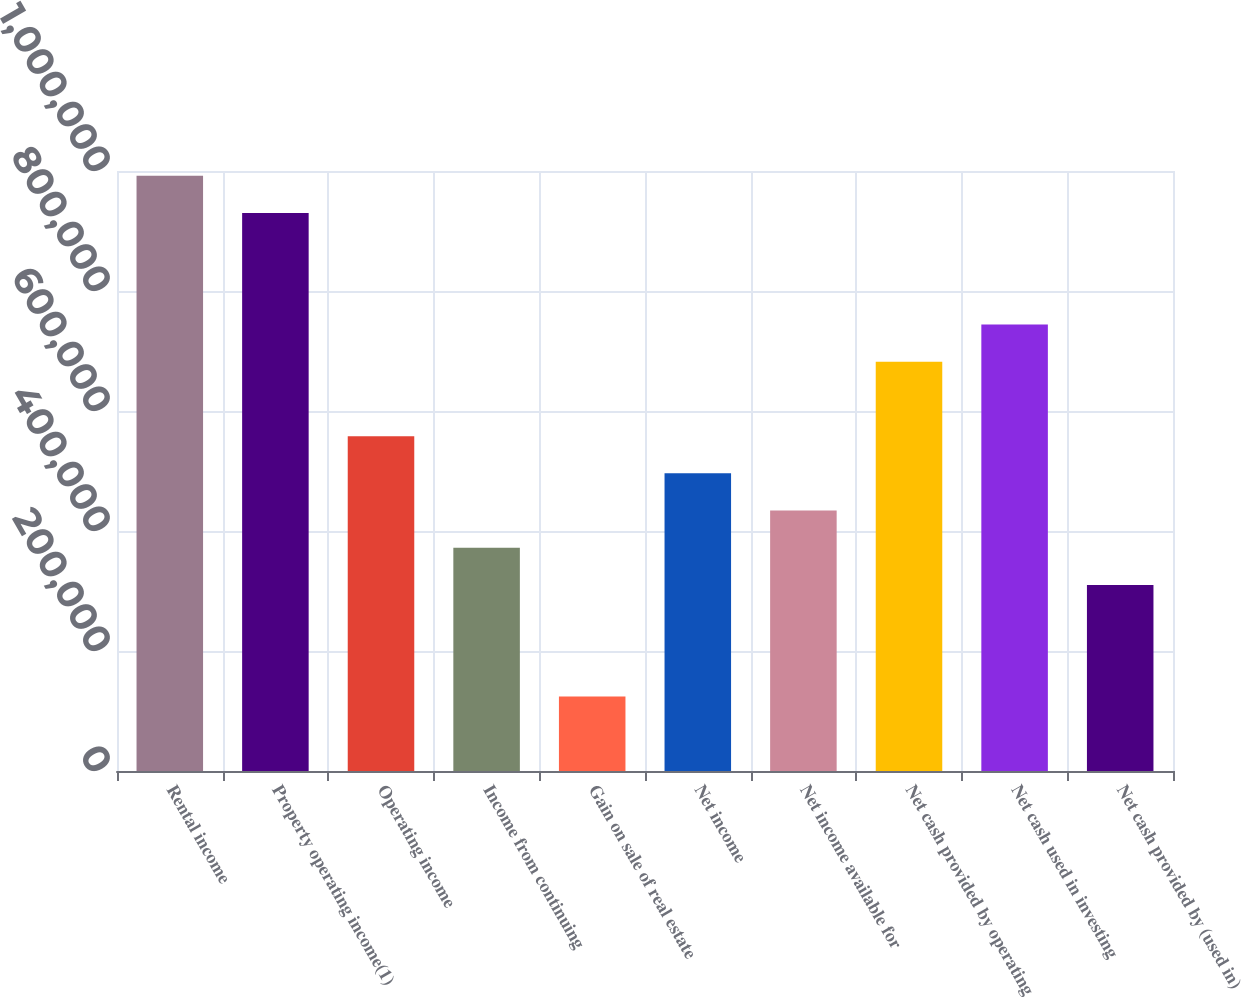Convert chart. <chart><loc_0><loc_0><loc_500><loc_500><bar_chart><fcel>Rental income<fcel>Property operating income(1)<fcel>Operating income<fcel>Income from continuing<fcel>Gain on sale of real estate<fcel>Net income<fcel>Net income available for<fcel>Net cash provided by operating<fcel>Net cash used in investing<fcel>Net cash provided by (used in)<nl><fcel>992141<fcel>930132<fcel>558080<fcel>372054<fcel>124020<fcel>496072<fcel>434063<fcel>682098<fcel>744106<fcel>310046<nl></chart> 